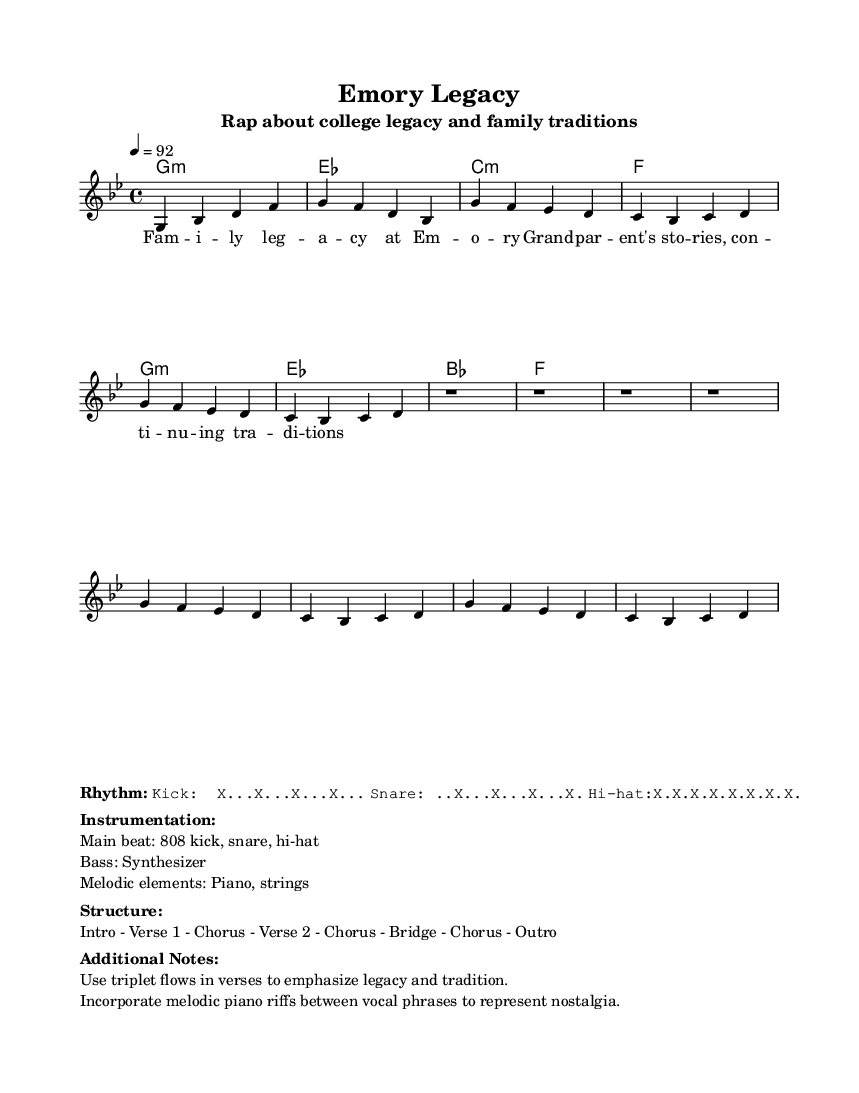What is the key signature of this music? The key signature is G minor, indicated by the presence of two flats in the signature. This can be determined from the beginning of the music stave where the key signature is displayed.
Answer: G minor What is the time signature used in the piece? The time signature is 4/4, which is represented at the beginning of the music. This means there are four beats in each measure and the quarter note gets one beat.
Answer: 4/4 What is the tempo marking? The tempo marking is 92 beats per minute, indicated at the start of the sheet music. This specifies how fast the piece should be played.
Answer: 92 How many verses are indicated in the structure? There are two verses indicated in the structure, as shown by the section labeling in the layout description of the music. This layout follows the pattern stated.
Answer: 2 What instruments are listed in the instrumentation? The main instruments listed are the 808 kick, snare, hi-hat, synthesizer for bass, and melodic elements include piano and strings, as mentioned in the instrumentation section of the markup.
Answer: 808 kick, snare, hi-hat, synthesizer, piano, strings What unique feature is emphasized in the verses? The unique feature emphasized in the verses is the use of triplet flows, which is mentioned in the additional notes section. This stylistic choice aims to express themes of legacy and tradition within the rap genre.
Answer: Triplet flows 